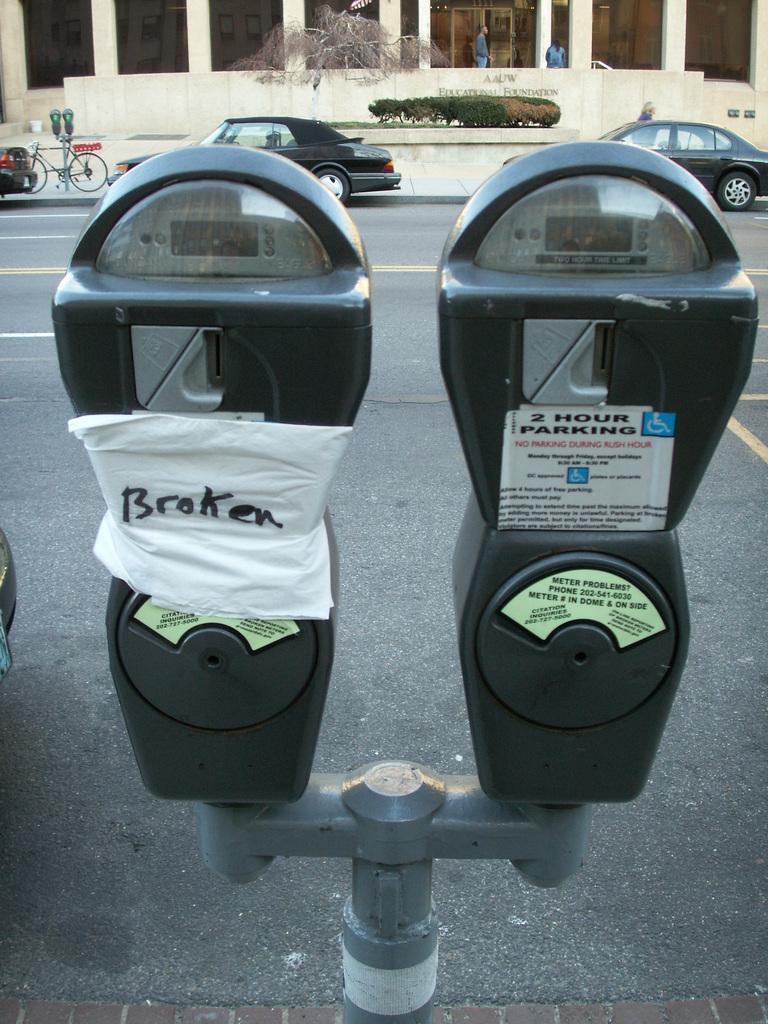How would you summarize this image in a sentence or two? In this image I can see a road and number of vehicles. I can also see few people and a cycle. Here I can see a parking meter. 